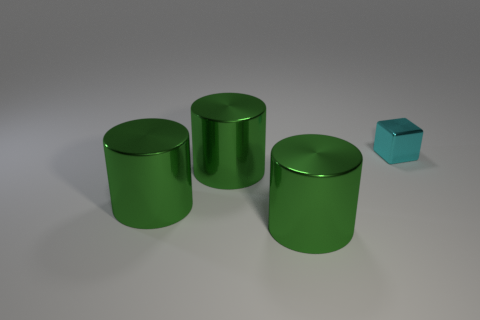Subtract all green cylinders. How many were subtracted if there are1green cylinders left? 2 Add 3 cyan shiny blocks. How many objects exist? 7 Subtract all cubes. How many objects are left? 3 Subtract 2 cylinders. How many cylinders are left? 1 Add 3 small cyan shiny cubes. How many small cyan shiny cubes are left? 4 Add 1 big shiny cylinders. How many big shiny cylinders exist? 4 Subtract 0 blue balls. How many objects are left? 4 Subtract all yellow cylinders. Subtract all gray blocks. How many cylinders are left? 3 Subtract all green metallic cylinders. Subtract all tiny metallic objects. How many objects are left? 0 